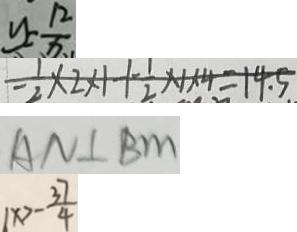Convert formula to latex. <formula><loc_0><loc_0><loc_500><loc_500>y = \frac { 1 2 } { x } 
 - \frac { 1 } { 2 } \times 2 \times 1 + \frac { 1 } { 2 } \times 1 \times 4 = 1 4 . 5 
 A N \bot B m 
 1 x > - \frac { 3 7 } { 4 }</formula> 